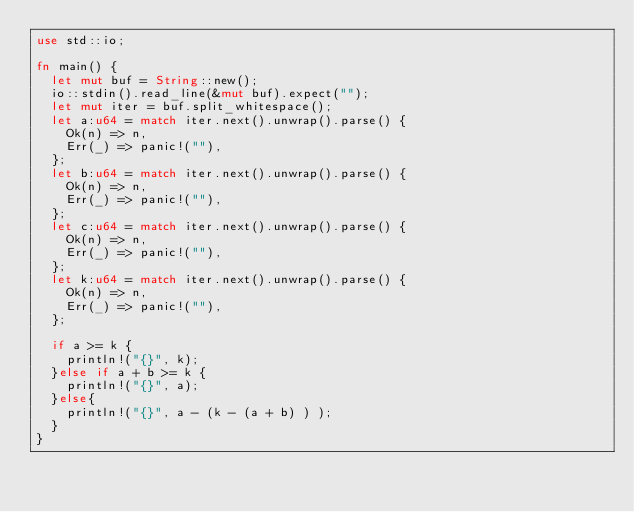<code> <loc_0><loc_0><loc_500><loc_500><_Rust_>use std::io;

fn main() {
	let mut buf = String::new();
	io::stdin().read_line(&mut buf).expect("");
	let mut iter = buf.split_whitespace();
	let a:u64 = match iter.next().unwrap().parse() {
		Ok(n) => n,
		Err(_) => panic!(""),
	};
	let b:u64 = match iter.next().unwrap().parse() {
		Ok(n) => n,
		Err(_) => panic!(""),
	};
	let c:u64 = match iter.next().unwrap().parse() {
		Ok(n) => n,
		Err(_) => panic!(""),
	};
	let k:u64 = match iter.next().unwrap().parse() {
		Ok(n) => n,
		Err(_) => panic!(""),
	};

	if a >= k {
		println!("{}", k);
	}else if a + b >= k {
		println!("{}", a);
	}else{
	 	println!("{}", a - (k - (a + b) ) );
	}
}</code> 